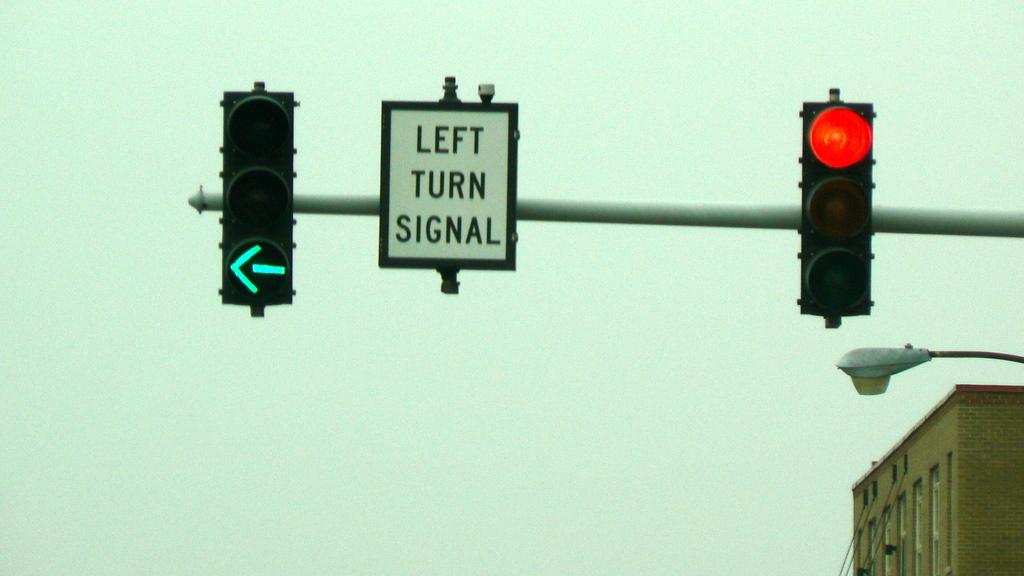What direction does the turn signal sign indicate?
Offer a very short reply. Left. What's the color of the light on the right side?
Your answer should be very brief. Red. 